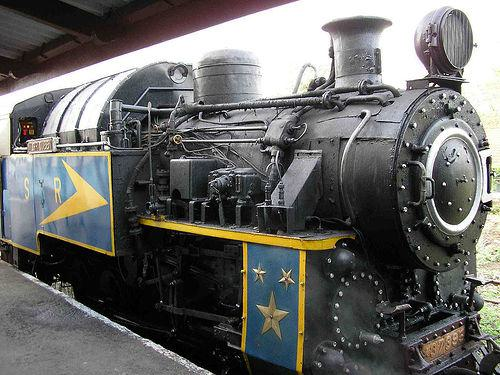What might have been the primary use for this type of train? This type of locomotive was likely used for hauling heavy freight or passenger service, given its robust build and the era it appears to come from. 